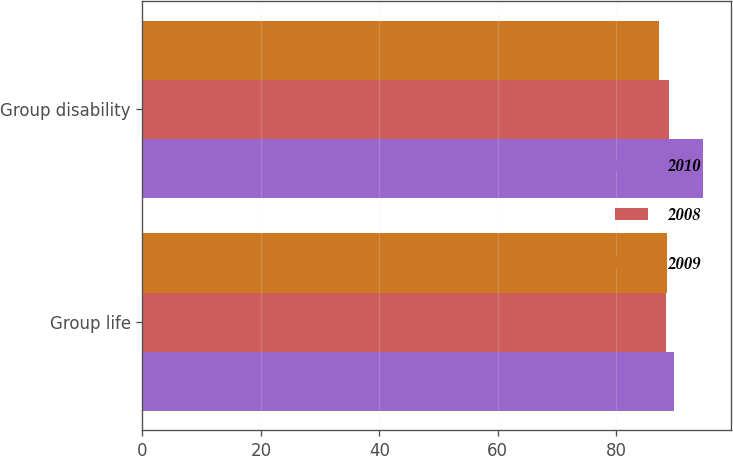Convert chart. <chart><loc_0><loc_0><loc_500><loc_500><stacked_bar_chart><ecel><fcel>Group life<fcel>Group disability<nl><fcel>2010<fcel>89.7<fcel>94.7<nl><fcel>2008<fcel>88.4<fcel>88.9<nl><fcel>2009<fcel>88.6<fcel>87.2<nl></chart> 